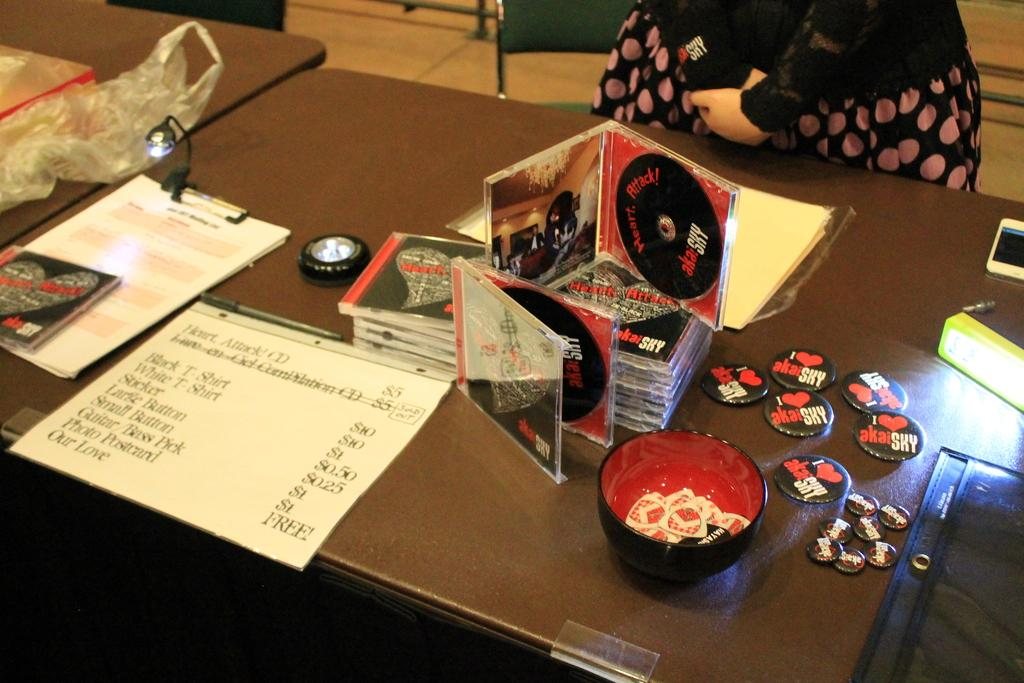What type of furniture is present in the image? There is a table in the image. What items are placed on the table? There are CD cases in a bundle, badges, a cup with coupons, and papers on the table. What type of poison is being used to grip the CD cases in the image? There is no poison or gripping action present in the image; the CD cases are simply bundled together on the table. 